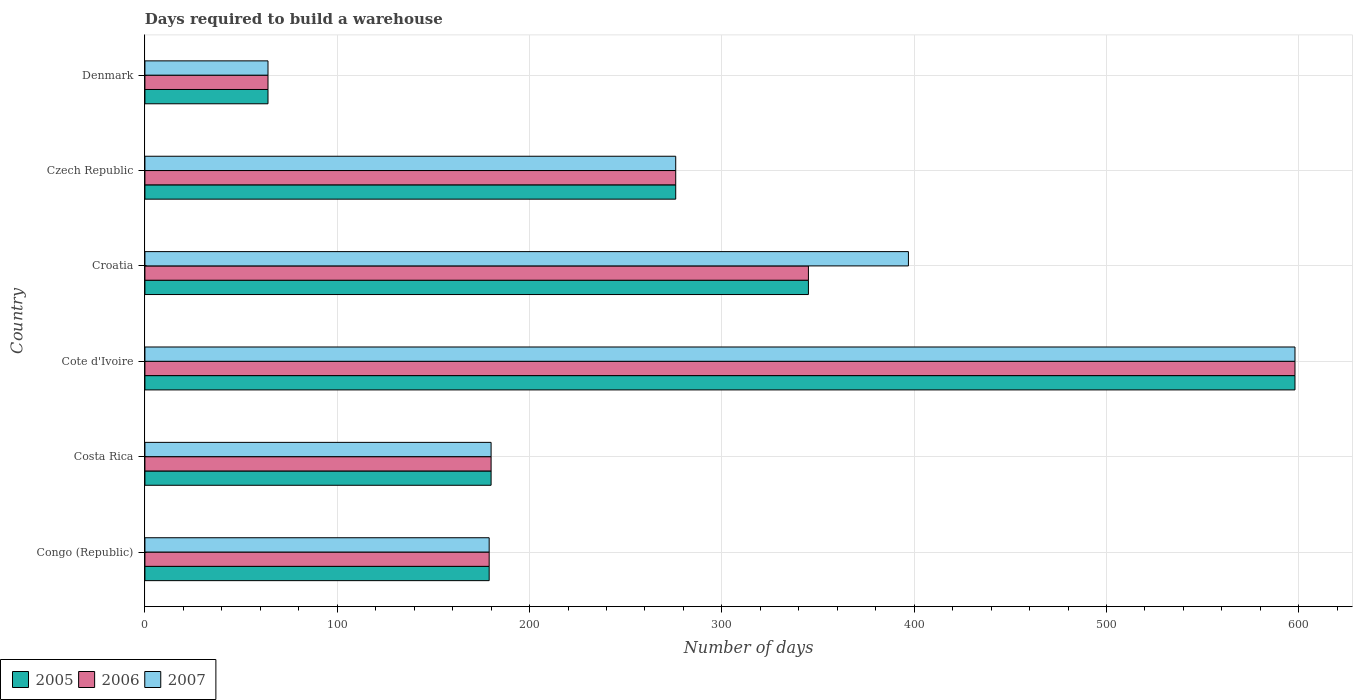How many different coloured bars are there?
Provide a short and direct response. 3. How many groups of bars are there?
Offer a terse response. 6. Are the number of bars on each tick of the Y-axis equal?
Your response must be concise. Yes. How many bars are there on the 3rd tick from the top?
Your answer should be compact. 3. What is the label of the 6th group of bars from the top?
Your answer should be very brief. Congo (Republic). What is the days required to build a warehouse in in 2005 in Costa Rica?
Ensure brevity in your answer.  180. Across all countries, what is the maximum days required to build a warehouse in in 2006?
Make the answer very short. 598. Across all countries, what is the minimum days required to build a warehouse in in 2005?
Ensure brevity in your answer.  64. In which country was the days required to build a warehouse in in 2007 maximum?
Ensure brevity in your answer.  Cote d'Ivoire. What is the total days required to build a warehouse in in 2005 in the graph?
Provide a short and direct response. 1642. What is the difference between the days required to build a warehouse in in 2006 in Czech Republic and that in Denmark?
Provide a succinct answer. 212. What is the difference between the days required to build a warehouse in in 2007 in Croatia and the days required to build a warehouse in in 2006 in Czech Republic?
Ensure brevity in your answer.  121. What is the average days required to build a warehouse in in 2007 per country?
Provide a short and direct response. 282.33. In how many countries, is the days required to build a warehouse in in 2006 greater than 380 days?
Your answer should be compact. 1. What is the ratio of the days required to build a warehouse in in 2005 in Costa Rica to that in Cote d'Ivoire?
Keep it short and to the point. 0.3. Is the days required to build a warehouse in in 2005 in Congo (Republic) less than that in Czech Republic?
Make the answer very short. Yes. Is the difference between the days required to build a warehouse in in 2005 in Costa Rica and Czech Republic greater than the difference between the days required to build a warehouse in in 2006 in Costa Rica and Czech Republic?
Offer a very short reply. No. What is the difference between the highest and the second highest days required to build a warehouse in in 2006?
Your answer should be very brief. 253. What is the difference between the highest and the lowest days required to build a warehouse in in 2007?
Offer a terse response. 534. In how many countries, is the days required to build a warehouse in in 2005 greater than the average days required to build a warehouse in in 2005 taken over all countries?
Your answer should be compact. 3. What does the 1st bar from the top in Denmark represents?
Keep it short and to the point. 2007. Is it the case that in every country, the sum of the days required to build a warehouse in in 2007 and days required to build a warehouse in in 2006 is greater than the days required to build a warehouse in in 2005?
Ensure brevity in your answer.  Yes. How many bars are there?
Ensure brevity in your answer.  18. How many countries are there in the graph?
Your answer should be compact. 6. Does the graph contain grids?
Your answer should be compact. Yes. How many legend labels are there?
Make the answer very short. 3. What is the title of the graph?
Your response must be concise. Days required to build a warehouse. What is the label or title of the X-axis?
Provide a short and direct response. Number of days. What is the Number of days in 2005 in Congo (Republic)?
Keep it short and to the point. 179. What is the Number of days of 2006 in Congo (Republic)?
Keep it short and to the point. 179. What is the Number of days in 2007 in Congo (Republic)?
Your response must be concise. 179. What is the Number of days of 2005 in Costa Rica?
Keep it short and to the point. 180. What is the Number of days of 2006 in Costa Rica?
Offer a terse response. 180. What is the Number of days of 2007 in Costa Rica?
Provide a short and direct response. 180. What is the Number of days in 2005 in Cote d'Ivoire?
Offer a terse response. 598. What is the Number of days of 2006 in Cote d'Ivoire?
Your answer should be compact. 598. What is the Number of days in 2007 in Cote d'Ivoire?
Offer a very short reply. 598. What is the Number of days in 2005 in Croatia?
Give a very brief answer. 345. What is the Number of days of 2006 in Croatia?
Make the answer very short. 345. What is the Number of days in 2007 in Croatia?
Keep it short and to the point. 397. What is the Number of days in 2005 in Czech Republic?
Your answer should be compact. 276. What is the Number of days of 2006 in Czech Republic?
Offer a terse response. 276. What is the Number of days in 2007 in Czech Republic?
Offer a very short reply. 276. What is the Number of days of 2005 in Denmark?
Provide a short and direct response. 64. What is the Number of days in 2006 in Denmark?
Offer a terse response. 64. What is the Number of days in 2007 in Denmark?
Offer a terse response. 64. Across all countries, what is the maximum Number of days of 2005?
Your answer should be very brief. 598. Across all countries, what is the maximum Number of days of 2006?
Provide a short and direct response. 598. Across all countries, what is the maximum Number of days in 2007?
Offer a very short reply. 598. What is the total Number of days of 2005 in the graph?
Give a very brief answer. 1642. What is the total Number of days in 2006 in the graph?
Your response must be concise. 1642. What is the total Number of days of 2007 in the graph?
Provide a succinct answer. 1694. What is the difference between the Number of days in 2005 in Congo (Republic) and that in Costa Rica?
Ensure brevity in your answer.  -1. What is the difference between the Number of days of 2006 in Congo (Republic) and that in Costa Rica?
Offer a terse response. -1. What is the difference between the Number of days of 2007 in Congo (Republic) and that in Costa Rica?
Your answer should be compact. -1. What is the difference between the Number of days in 2005 in Congo (Republic) and that in Cote d'Ivoire?
Your response must be concise. -419. What is the difference between the Number of days in 2006 in Congo (Republic) and that in Cote d'Ivoire?
Ensure brevity in your answer.  -419. What is the difference between the Number of days of 2007 in Congo (Republic) and that in Cote d'Ivoire?
Your answer should be very brief. -419. What is the difference between the Number of days in 2005 in Congo (Republic) and that in Croatia?
Your response must be concise. -166. What is the difference between the Number of days of 2006 in Congo (Republic) and that in Croatia?
Your response must be concise. -166. What is the difference between the Number of days in 2007 in Congo (Republic) and that in Croatia?
Your answer should be compact. -218. What is the difference between the Number of days in 2005 in Congo (Republic) and that in Czech Republic?
Offer a terse response. -97. What is the difference between the Number of days of 2006 in Congo (Republic) and that in Czech Republic?
Your answer should be compact. -97. What is the difference between the Number of days in 2007 in Congo (Republic) and that in Czech Republic?
Offer a very short reply. -97. What is the difference between the Number of days of 2005 in Congo (Republic) and that in Denmark?
Your response must be concise. 115. What is the difference between the Number of days of 2006 in Congo (Republic) and that in Denmark?
Your response must be concise. 115. What is the difference between the Number of days of 2007 in Congo (Republic) and that in Denmark?
Provide a succinct answer. 115. What is the difference between the Number of days in 2005 in Costa Rica and that in Cote d'Ivoire?
Offer a terse response. -418. What is the difference between the Number of days in 2006 in Costa Rica and that in Cote d'Ivoire?
Keep it short and to the point. -418. What is the difference between the Number of days of 2007 in Costa Rica and that in Cote d'Ivoire?
Your answer should be compact. -418. What is the difference between the Number of days of 2005 in Costa Rica and that in Croatia?
Offer a terse response. -165. What is the difference between the Number of days of 2006 in Costa Rica and that in Croatia?
Your response must be concise. -165. What is the difference between the Number of days in 2007 in Costa Rica and that in Croatia?
Your answer should be very brief. -217. What is the difference between the Number of days in 2005 in Costa Rica and that in Czech Republic?
Give a very brief answer. -96. What is the difference between the Number of days in 2006 in Costa Rica and that in Czech Republic?
Offer a very short reply. -96. What is the difference between the Number of days of 2007 in Costa Rica and that in Czech Republic?
Provide a short and direct response. -96. What is the difference between the Number of days of 2005 in Costa Rica and that in Denmark?
Your answer should be compact. 116. What is the difference between the Number of days in 2006 in Costa Rica and that in Denmark?
Make the answer very short. 116. What is the difference between the Number of days in 2007 in Costa Rica and that in Denmark?
Offer a terse response. 116. What is the difference between the Number of days in 2005 in Cote d'Ivoire and that in Croatia?
Make the answer very short. 253. What is the difference between the Number of days of 2006 in Cote d'Ivoire and that in Croatia?
Offer a very short reply. 253. What is the difference between the Number of days in 2007 in Cote d'Ivoire and that in Croatia?
Ensure brevity in your answer.  201. What is the difference between the Number of days of 2005 in Cote d'Ivoire and that in Czech Republic?
Give a very brief answer. 322. What is the difference between the Number of days in 2006 in Cote d'Ivoire and that in Czech Republic?
Offer a very short reply. 322. What is the difference between the Number of days of 2007 in Cote d'Ivoire and that in Czech Republic?
Ensure brevity in your answer.  322. What is the difference between the Number of days of 2005 in Cote d'Ivoire and that in Denmark?
Offer a terse response. 534. What is the difference between the Number of days in 2006 in Cote d'Ivoire and that in Denmark?
Make the answer very short. 534. What is the difference between the Number of days in 2007 in Cote d'Ivoire and that in Denmark?
Offer a terse response. 534. What is the difference between the Number of days in 2005 in Croatia and that in Czech Republic?
Your answer should be very brief. 69. What is the difference between the Number of days of 2007 in Croatia and that in Czech Republic?
Make the answer very short. 121. What is the difference between the Number of days of 2005 in Croatia and that in Denmark?
Keep it short and to the point. 281. What is the difference between the Number of days in 2006 in Croatia and that in Denmark?
Keep it short and to the point. 281. What is the difference between the Number of days in 2007 in Croatia and that in Denmark?
Offer a very short reply. 333. What is the difference between the Number of days of 2005 in Czech Republic and that in Denmark?
Your answer should be very brief. 212. What is the difference between the Number of days in 2006 in Czech Republic and that in Denmark?
Make the answer very short. 212. What is the difference between the Number of days in 2007 in Czech Republic and that in Denmark?
Your answer should be very brief. 212. What is the difference between the Number of days in 2005 in Congo (Republic) and the Number of days in 2006 in Costa Rica?
Make the answer very short. -1. What is the difference between the Number of days in 2005 in Congo (Republic) and the Number of days in 2006 in Cote d'Ivoire?
Keep it short and to the point. -419. What is the difference between the Number of days in 2005 in Congo (Republic) and the Number of days in 2007 in Cote d'Ivoire?
Keep it short and to the point. -419. What is the difference between the Number of days of 2006 in Congo (Republic) and the Number of days of 2007 in Cote d'Ivoire?
Give a very brief answer. -419. What is the difference between the Number of days in 2005 in Congo (Republic) and the Number of days in 2006 in Croatia?
Offer a very short reply. -166. What is the difference between the Number of days of 2005 in Congo (Republic) and the Number of days of 2007 in Croatia?
Ensure brevity in your answer.  -218. What is the difference between the Number of days in 2006 in Congo (Republic) and the Number of days in 2007 in Croatia?
Give a very brief answer. -218. What is the difference between the Number of days in 2005 in Congo (Republic) and the Number of days in 2006 in Czech Republic?
Keep it short and to the point. -97. What is the difference between the Number of days in 2005 in Congo (Republic) and the Number of days in 2007 in Czech Republic?
Your answer should be compact. -97. What is the difference between the Number of days in 2006 in Congo (Republic) and the Number of days in 2007 in Czech Republic?
Give a very brief answer. -97. What is the difference between the Number of days in 2005 in Congo (Republic) and the Number of days in 2006 in Denmark?
Offer a terse response. 115. What is the difference between the Number of days of 2005 in Congo (Republic) and the Number of days of 2007 in Denmark?
Make the answer very short. 115. What is the difference between the Number of days of 2006 in Congo (Republic) and the Number of days of 2007 in Denmark?
Make the answer very short. 115. What is the difference between the Number of days in 2005 in Costa Rica and the Number of days in 2006 in Cote d'Ivoire?
Provide a succinct answer. -418. What is the difference between the Number of days of 2005 in Costa Rica and the Number of days of 2007 in Cote d'Ivoire?
Offer a terse response. -418. What is the difference between the Number of days in 2006 in Costa Rica and the Number of days in 2007 in Cote d'Ivoire?
Make the answer very short. -418. What is the difference between the Number of days in 2005 in Costa Rica and the Number of days in 2006 in Croatia?
Offer a very short reply. -165. What is the difference between the Number of days in 2005 in Costa Rica and the Number of days in 2007 in Croatia?
Your response must be concise. -217. What is the difference between the Number of days of 2006 in Costa Rica and the Number of days of 2007 in Croatia?
Your answer should be very brief. -217. What is the difference between the Number of days in 2005 in Costa Rica and the Number of days in 2006 in Czech Republic?
Your answer should be compact. -96. What is the difference between the Number of days of 2005 in Costa Rica and the Number of days of 2007 in Czech Republic?
Give a very brief answer. -96. What is the difference between the Number of days in 2006 in Costa Rica and the Number of days in 2007 in Czech Republic?
Ensure brevity in your answer.  -96. What is the difference between the Number of days in 2005 in Costa Rica and the Number of days in 2006 in Denmark?
Keep it short and to the point. 116. What is the difference between the Number of days in 2005 in Costa Rica and the Number of days in 2007 in Denmark?
Ensure brevity in your answer.  116. What is the difference between the Number of days in 2006 in Costa Rica and the Number of days in 2007 in Denmark?
Provide a succinct answer. 116. What is the difference between the Number of days in 2005 in Cote d'Ivoire and the Number of days in 2006 in Croatia?
Your response must be concise. 253. What is the difference between the Number of days of 2005 in Cote d'Ivoire and the Number of days of 2007 in Croatia?
Keep it short and to the point. 201. What is the difference between the Number of days of 2006 in Cote d'Ivoire and the Number of days of 2007 in Croatia?
Your answer should be compact. 201. What is the difference between the Number of days in 2005 in Cote d'Ivoire and the Number of days in 2006 in Czech Republic?
Ensure brevity in your answer.  322. What is the difference between the Number of days of 2005 in Cote d'Ivoire and the Number of days of 2007 in Czech Republic?
Offer a terse response. 322. What is the difference between the Number of days in 2006 in Cote d'Ivoire and the Number of days in 2007 in Czech Republic?
Provide a succinct answer. 322. What is the difference between the Number of days of 2005 in Cote d'Ivoire and the Number of days of 2006 in Denmark?
Make the answer very short. 534. What is the difference between the Number of days in 2005 in Cote d'Ivoire and the Number of days in 2007 in Denmark?
Offer a terse response. 534. What is the difference between the Number of days of 2006 in Cote d'Ivoire and the Number of days of 2007 in Denmark?
Provide a short and direct response. 534. What is the difference between the Number of days in 2005 in Croatia and the Number of days in 2007 in Czech Republic?
Make the answer very short. 69. What is the difference between the Number of days of 2006 in Croatia and the Number of days of 2007 in Czech Republic?
Your response must be concise. 69. What is the difference between the Number of days in 2005 in Croatia and the Number of days in 2006 in Denmark?
Your answer should be very brief. 281. What is the difference between the Number of days in 2005 in Croatia and the Number of days in 2007 in Denmark?
Provide a succinct answer. 281. What is the difference between the Number of days in 2006 in Croatia and the Number of days in 2007 in Denmark?
Your response must be concise. 281. What is the difference between the Number of days of 2005 in Czech Republic and the Number of days of 2006 in Denmark?
Your answer should be very brief. 212. What is the difference between the Number of days in 2005 in Czech Republic and the Number of days in 2007 in Denmark?
Keep it short and to the point. 212. What is the difference between the Number of days in 2006 in Czech Republic and the Number of days in 2007 in Denmark?
Offer a terse response. 212. What is the average Number of days in 2005 per country?
Make the answer very short. 273.67. What is the average Number of days of 2006 per country?
Provide a short and direct response. 273.67. What is the average Number of days of 2007 per country?
Your answer should be compact. 282.33. What is the difference between the Number of days in 2005 and Number of days in 2007 in Congo (Republic)?
Provide a short and direct response. 0. What is the difference between the Number of days of 2006 and Number of days of 2007 in Congo (Republic)?
Ensure brevity in your answer.  0. What is the difference between the Number of days in 2005 and Number of days in 2006 in Costa Rica?
Make the answer very short. 0. What is the difference between the Number of days of 2005 and Number of days of 2007 in Costa Rica?
Offer a very short reply. 0. What is the difference between the Number of days in 2006 and Number of days in 2007 in Costa Rica?
Provide a succinct answer. 0. What is the difference between the Number of days of 2005 and Number of days of 2006 in Cote d'Ivoire?
Make the answer very short. 0. What is the difference between the Number of days in 2006 and Number of days in 2007 in Cote d'Ivoire?
Provide a short and direct response. 0. What is the difference between the Number of days of 2005 and Number of days of 2006 in Croatia?
Offer a very short reply. 0. What is the difference between the Number of days in 2005 and Number of days in 2007 in Croatia?
Ensure brevity in your answer.  -52. What is the difference between the Number of days of 2006 and Number of days of 2007 in Croatia?
Keep it short and to the point. -52. What is the difference between the Number of days of 2005 and Number of days of 2006 in Czech Republic?
Provide a short and direct response. 0. What is the difference between the Number of days in 2005 and Number of days in 2006 in Denmark?
Offer a terse response. 0. What is the difference between the Number of days in 2005 and Number of days in 2007 in Denmark?
Offer a terse response. 0. What is the ratio of the Number of days of 2005 in Congo (Republic) to that in Costa Rica?
Make the answer very short. 0.99. What is the ratio of the Number of days of 2005 in Congo (Republic) to that in Cote d'Ivoire?
Your response must be concise. 0.3. What is the ratio of the Number of days in 2006 in Congo (Republic) to that in Cote d'Ivoire?
Give a very brief answer. 0.3. What is the ratio of the Number of days in 2007 in Congo (Republic) to that in Cote d'Ivoire?
Offer a terse response. 0.3. What is the ratio of the Number of days in 2005 in Congo (Republic) to that in Croatia?
Keep it short and to the point. 0.52. What is the ratio of the Number of days of 2006 in Congo (Republic) to that in Croatia?
Keep it short and to the point. 0.52. What is the ratio of the Number of days of 2007 in Congo (Republic) to that in Croatia?
Offer a very short reply. 0.45. What is the ratio of the Number of days in 2005 in Congo (Republic) to that in Czech Republic?
Your answer should be very brief. 0.65. What is the ratio of the Number of days of 2006 in Congo (Republic) to that in Czech Republic?
Offer a very short reply. 0.65. What is the ratio of the Number of days of 2007 in Congo (Republic) to that in Czech Republic?
Your answer should be compact. 0.65. What is the ratio of the Number of days in 2005 in Congo (Republic) to that in Denmark?
Offer a very short reply. 2.8. What is the ratio of the Number of days in 2006 in Congo (Republic) to that in Denmark?
Your response must be concise. 2.8. What is the ratio of the Number of days of 2007 in Congo (Republic) to that in Denmark?
Your answer should be compact. 2.8. What is the ratio of the Number of days in 2005 in Costa Rica to that in Cote d'Ivoire?
Provide a short and direct response. 0.3. What is the ratio of the Number of days of 2006 in Costa Rica to that in Cote d'Ivoire?
Offer a very short reply. 0.3. What is the ratio of the Number of days of 2007 in Costa Rica to that in Cote d'Ivoire?
Your answer should be compact. 0.3. What is the ratio of the Number of days in 2005 in Costa Rica to that in Croatia?
Provide a short and direct response. 0.52. What is the ratio of the Number of days in 2006 in Costa Rica to that in Croatia?
Make the answer very short. 0.52. What is the ratio of the Number of days of 2007 in Costa Rica to that in Croatia?
Make the answer very short. 0.45. What is the ratio of the Number of days in 2005 in Costa Rica to that in Czech Republic?
Keep it short and to the point. 0.65. What is the ratio of the Number of days of 2006 in Costa Rica to that in Czech Republic?
Your response must be concise. 0.65. What is the ratio of the Number of days in 2007 in Costa Rica to that in Czech Republic?
Provide a short and direct response. 0.65. What is the ratio of the Number of days of 2005 in Costa Rica to that in Denmark?
Provide a succinct answer. 2.81. What is the ratio of the Number of days of 2006 in Costa Rica to that in Denmark?
Your response must be concise. 2.81. What is the ratio of the Number of days of 2007 in Costa Rica to that in Denmark?
Offer a terse response. 2.81. What is the ratio of the Number of days of 2005 in Cote d'Ivoire to that in Croatia?
Keep it short and to the point. 1.73. What is the ratio of the Number of days in 2006 in Cote d'Ivoire to that in Croatia?
Offer a terse response. 1.73. What is the ratio of the Number of days in 2007 in Cote d'Ivoire to that in Croatia?
Provide a succinct answer. 1.51. What is the ratio of the Number of days of 2005 in Cote d'Ivoire to that in Czech Republic?
Keep it short and to the point. 2.17. What is the ratio of the Number of days of 2006 in Cote d'Ivoire to that in Czech Republic?
Make the answer very short. 2.17. What is the ratio of the Number of days of 2007 in Cote d'Ivoire to that in Czech Republic?
Your response must be concise. 2.17. What is the ratio of the Number of days of 2005 in Cote d'Ivoire to that in Denmark?
Give a very brief answer. 9.34. What is the ratio of the Number of days of 2006 in Cote d'Ivoire to that in Denmark?
Offer a very short reply. 9.34. What is the ratio of the Number of days of 2007 in Cote d'Ivoire to that in Denmark?
Your response must be concise. 9.34. What is the ratio of the Number of days in 2005 in Croatia to that in Czech Republic?
Offer a very short reply. 1.25. What is the ratio of the Number of days in 2006 in Croatia to that in Czech Republic?
Offer a very short reply. 1.25. What is the ratio of the Number of days of 2007 in Croatia to that in Czech Republic?
Provide a short and direct response. 1.44. What is the ratio of the Number of days in 2005 in Croatia to that in Denmark?
Keep it short and to the point. 5.39. What is the ratio of the Number of days in 2006 in Croatia to that in Denmark?
Give a very brief answer. 5.39. What is the ratio of the Number of days of 2007 in Croatia to that in Denmark?
Your answer should be compact. 6.2. What is the ratio of the Number of days of 2005 in Czech Republic to that in Denmark?
Your response must be concise. 4.31. What is the ratio of the Number of days of 2006 in Czech Republic to that in Denmark?
Your answer should be compact. 4.31. What is the ratio of the Number of days of 2007 in Czech Republic to that in Denmark?
Offer a very short reply. 4.31. What is the difference between the highest and the second highest Number of days in 2005?
Ensure brevity in your answer.  253. What is the difference between the highest and the second highest Number of days in 2006?
Your answer should be compact. 253. What is the difference between the highest and the second highest Number of days in 2007?
Provide a short and direct response. 201. What is the difference between the highest and the lowest Number of days of 2005?
Your answer should be very brief. 534. What is the difference between the highest and the lowest Number of days of 2006?
Provide a succinct answer. 534. What is the difference between the highest and the lowest Number of days of 2007?
Your response must be concise. 534. 